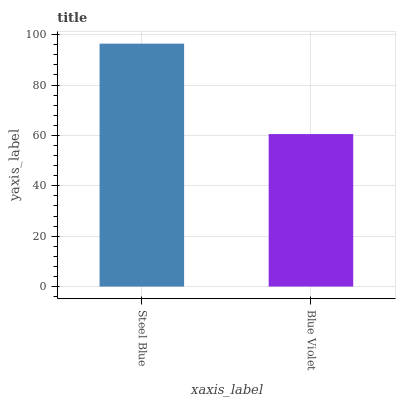Is Blue Violet the maximum?
Answer yes or no. No. Is Steel Blue greater than Blue Violet?
Answer yes or no. Yes. Is Blue Violet less than Steel Blue?
Answer yes or no. Yes. Is Blue Violet greater than Steel Blue?
Answer yes or no. No. Is Steel Blue less than Blue Violet?
Answer yes or no. No. Is Steel Blue the high median?
Answer yes or no. Yes. Is Blue Violet the low median?
Answer yes or no. Yes. Is Blue Violet the high median?
Answer yes or no. No. Is Steel Blue the low median?
Answer yes or no. No. 